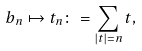<formula> <loc_0><loc_0><loc_500><loc_500>b _ { n } \mapsto t _ { n } \colon = \sum _ { | t | = n } t ,</formula> 